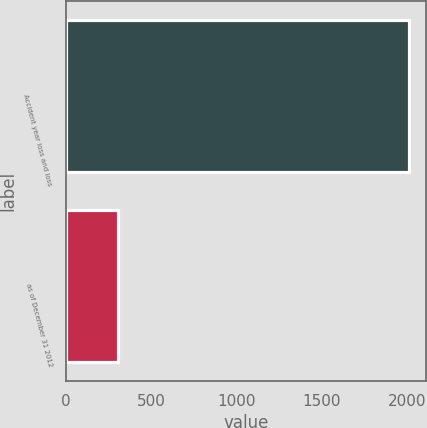<chart> <loc_0><loc_0><loc_500><loc_500><bar_chart><fcel>Accident year loss and loss<fcel>as of December 31 2012<nl><fcel>2012<fcel>306<nl></chart> 